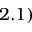Convert formula to latex. <formula><loc_0><loc_0><loc_500><loc_500>2 . 1 )</formula> 